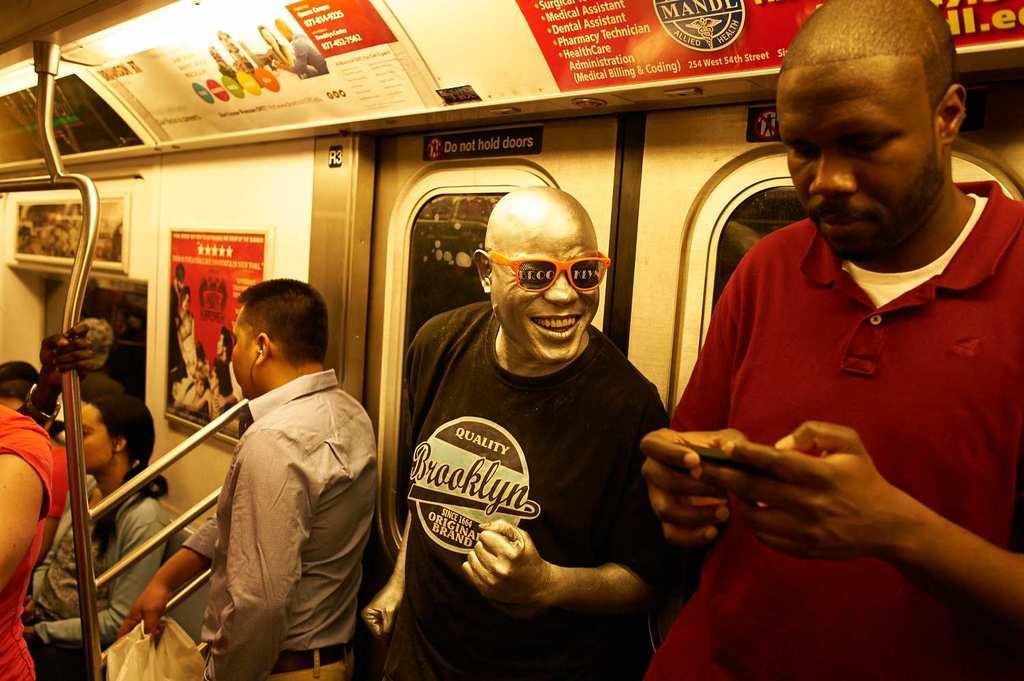Can you describe this image briefly? In this picture, we can see an inner view of a train, we can see a few people standing and a few are holding some objects, and a few are sitting, and a person is with gold paint, we can see poster with some text and images on it, we can see doors, and some metallic objects. 